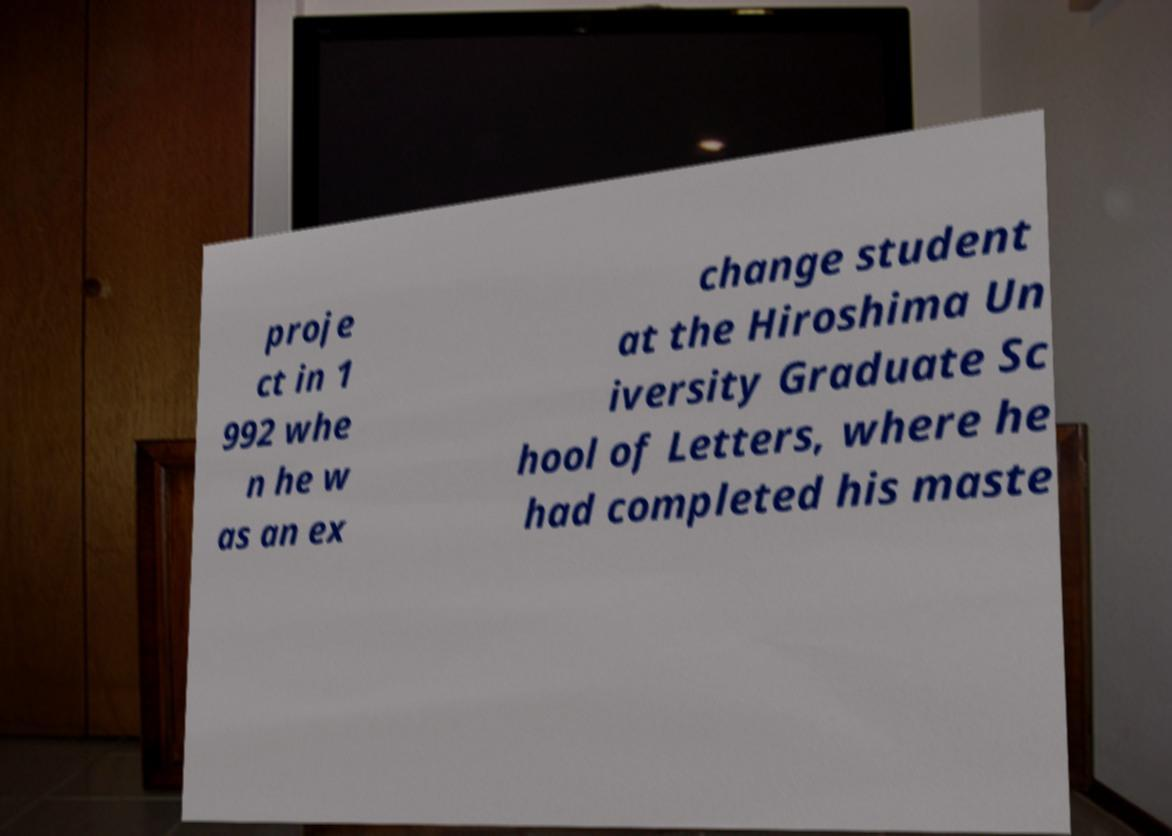For documentation purposes, I need the text within this image transcribed. Could you provide that? proje ct in 1 992 whe n he w as an ex change student at the Hiroshima Un iversity Graduate Sc hool of Letters, where he had completed his maste 